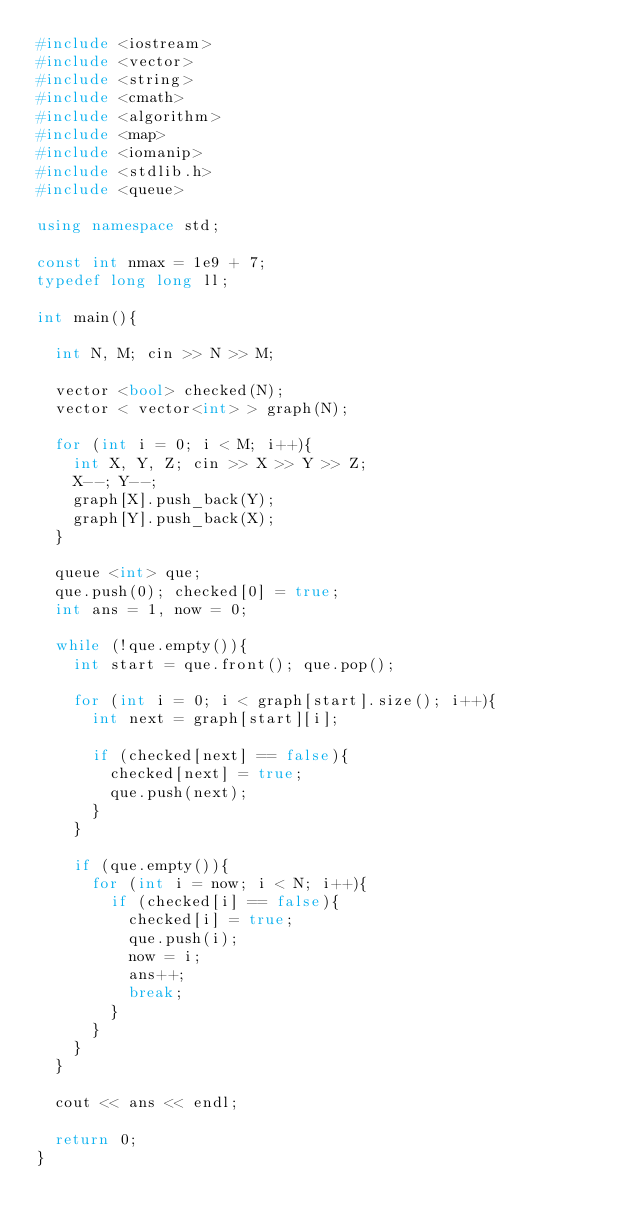<code> <loc_0><loc_0><loc_500><loc_500><_C++_>#include <iostream>
#include <vector>
#include <string>
#include <cmath>
#include <algorithm>
#include <map>
#include <iomanip>
#include <stdlib.h>
#include <queue>

using namespace std;

const int nmax = 1e9 + 7;
typedef long long ll;

int main(){
  
  int N, M; cin >> N >> M;
  
  vector <bool> checked(N);
  vector < vector<int> > graph(N);

  for (int i = 0; i < M; i++){
    int X, Y, Z; cin >> X >> Y >> Z;
    X--; Y--;
    graph[X].push_back(Y);
    graph[Y].push_back(X);
  }
  
  queue <int> que;
  que.push(0); checked[0] = true;
  int ans = 1, now = 0;

  while (!que.empty()){
    int start = que.front(); que.pop();

    for (int i = 0; i < graph[start].size(); i++){
      int next = graph[start][i];

      if (checked[next] == false){
        checked[next] = true;
        que.push(next);
      }
    }
    
    if (que.empty()){
      for (int i = now; i < N; i++){
        if (checked[i] == false){
          checked[i] = true;
          que.push(i);
          now = i;
          ans++;
          break;
        }
      }
    }
  }
  
  cout << ans << endl;

  return 0;
}
</code> 